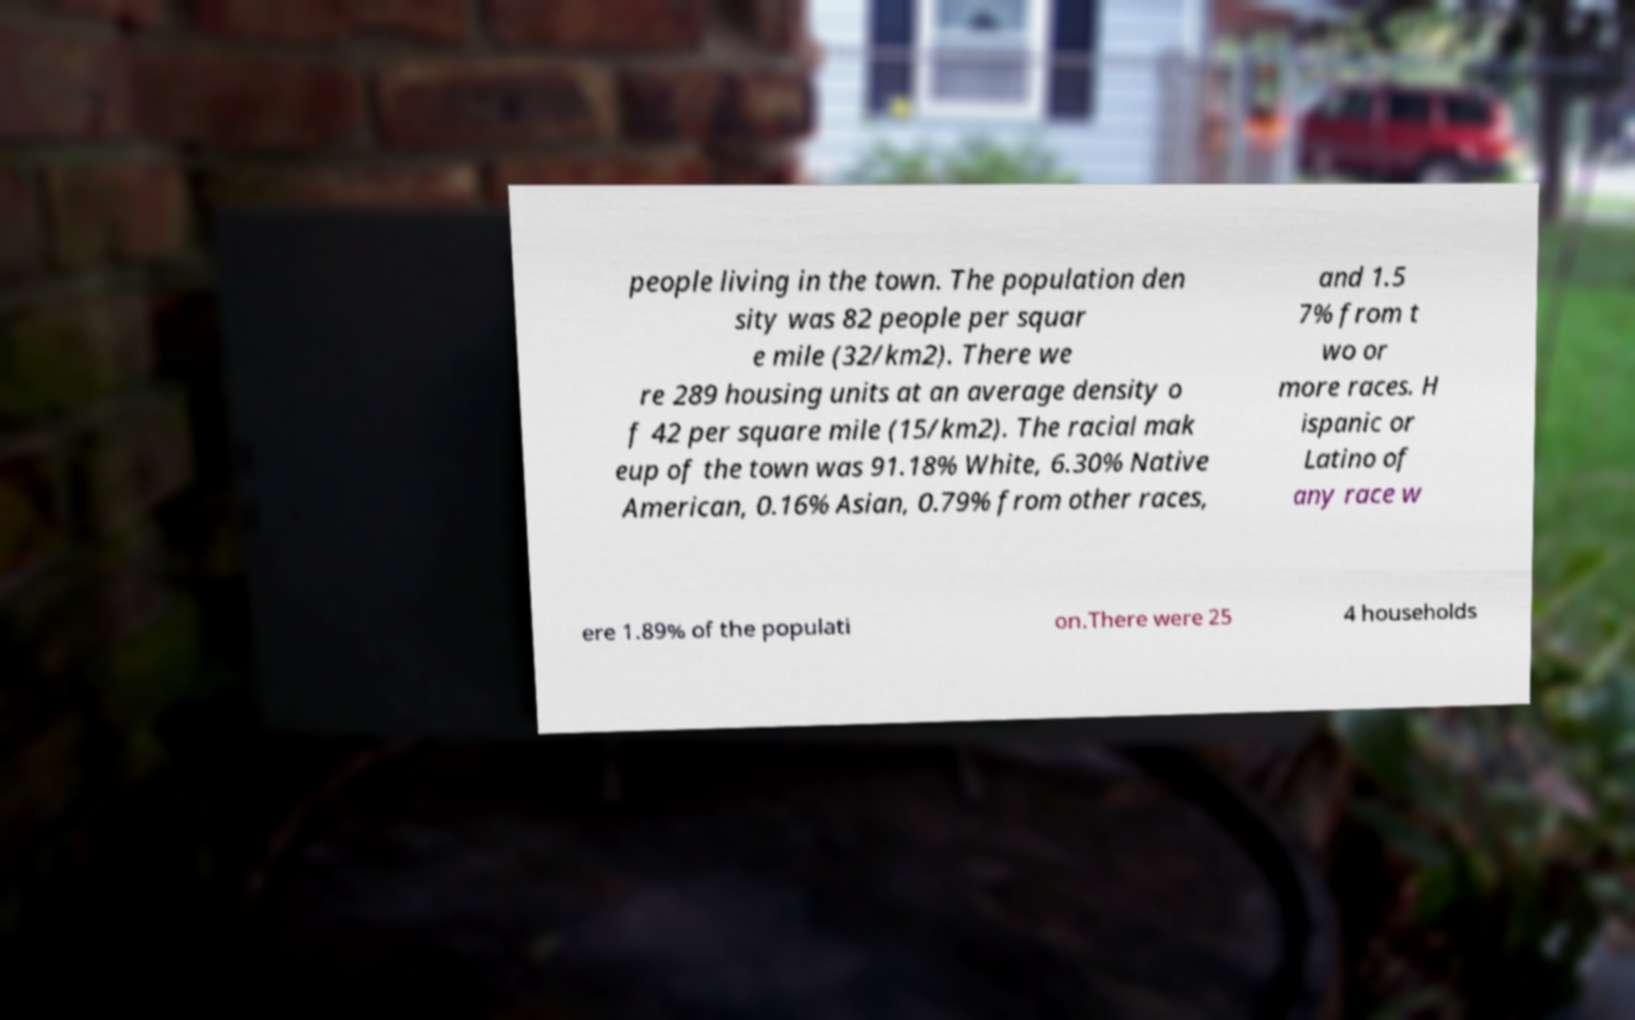I need the written content from this picture converted into text. Can you do that? people living in the town. The population den sity was 82 people per squar e mile (32/km2). There we re 289 housing units at an average density o f 42 per square mile (15/km2). The racial mak eup of the town was 91.18% White, 6.30% Native American, 0.16% Asian, 0.79% from other races, and 1.5 7% from t wo or more races. H ispanic or Latino of any race w ere 1.89% of the populati on.There were 25 4 households 